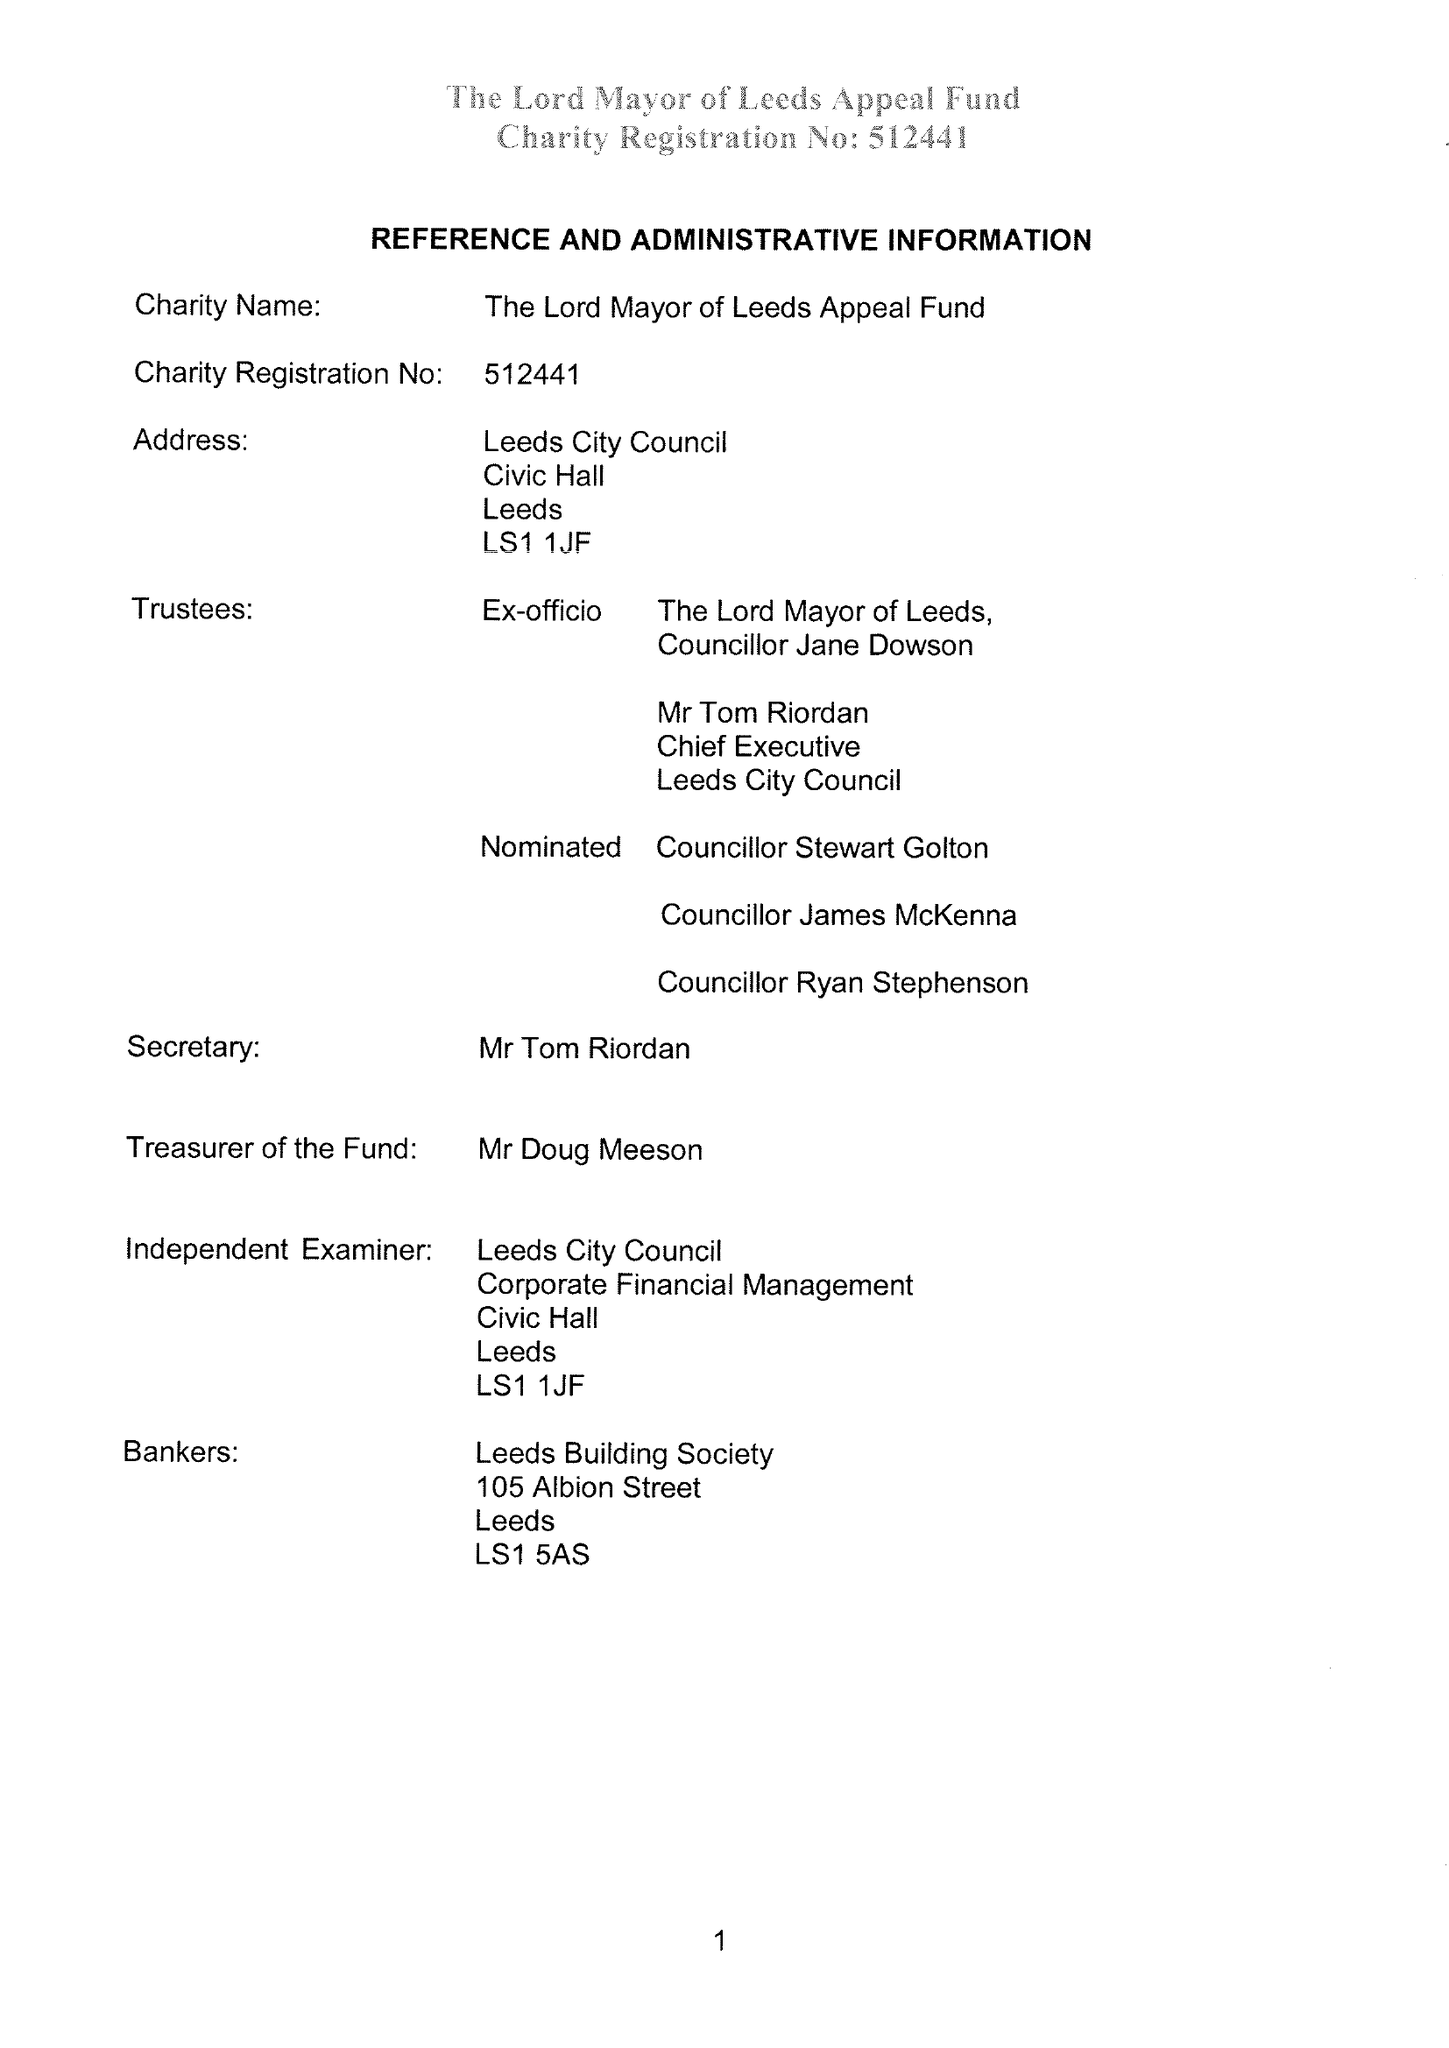What is the value for the address__street_line?
Answer the question using a single word or phrase. None 